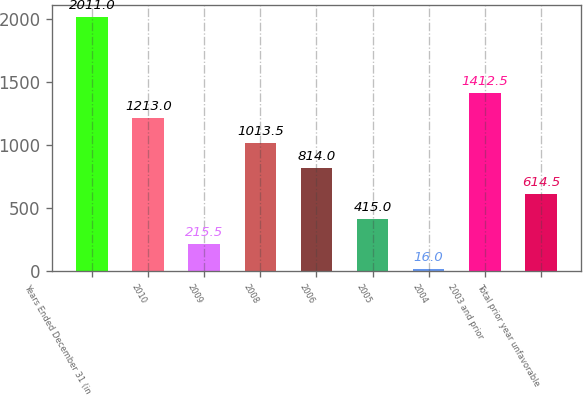Convert chart. <chart><loc_0><loc_0><loc_500><loc_500><bar_chart><fcel>Years Ended December 31 (in<fcel>2010<fcel>2009<fcel>2008<fcel>2006<fcel>2005<fcel>2004<fcel>2003 and prior<fcel>Total prior year unfavorable<nl><fcel>2011<fcel>1213<fcel>215.5<fcel>1013.5<fcel>814<fcel>415<fcel>16<fcel>1412.5<fcel>614.5<nl></chart> 